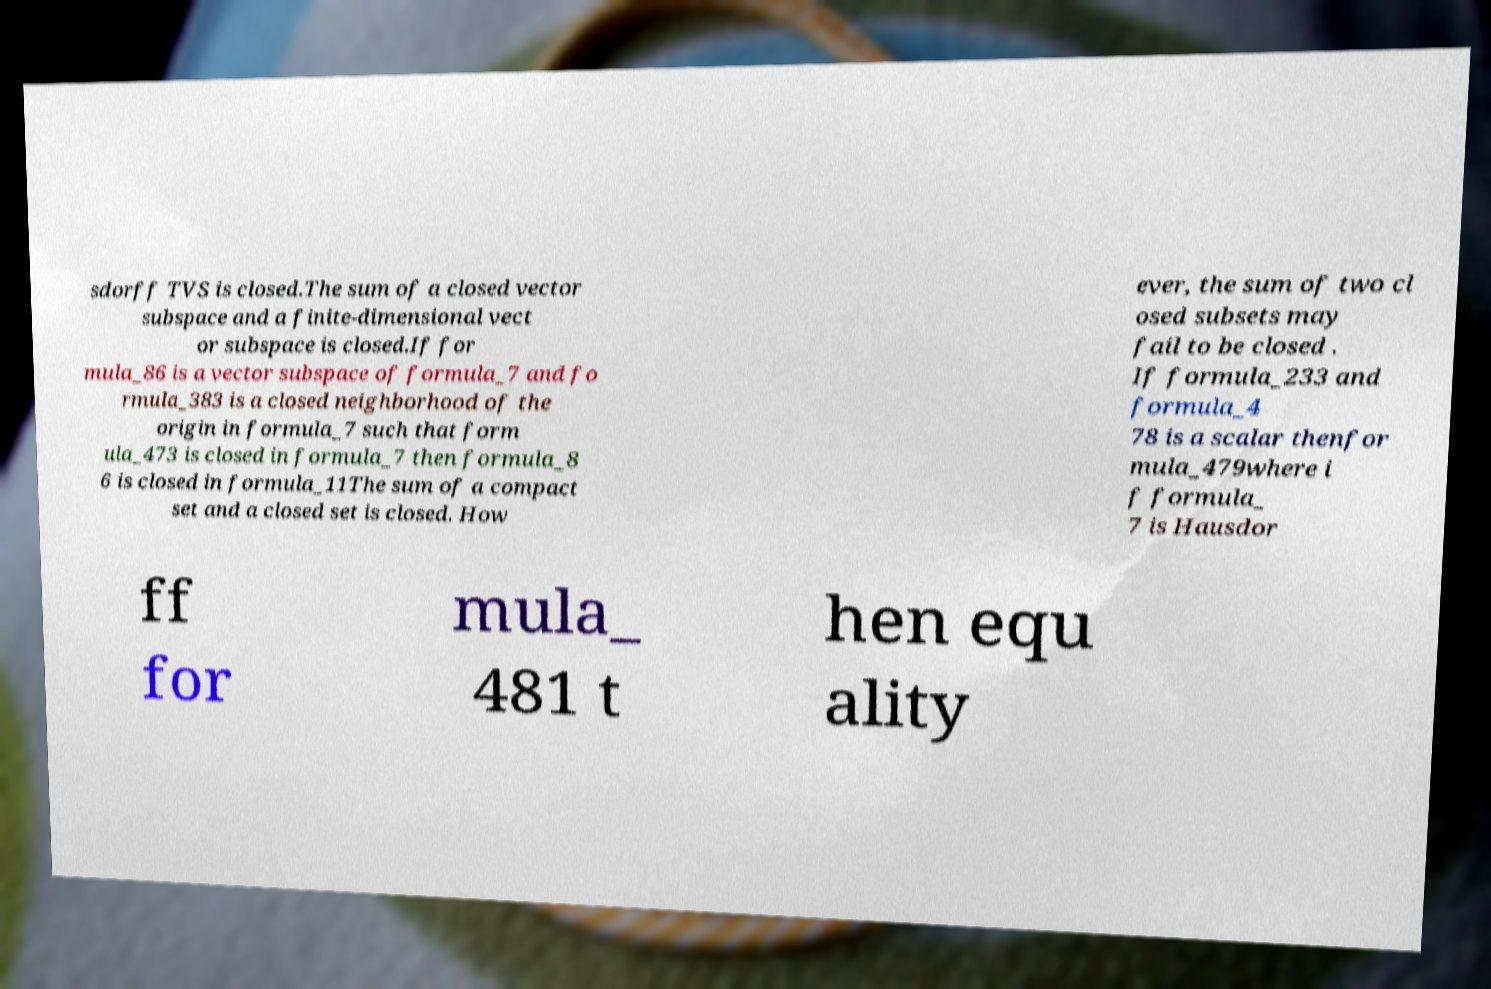I need the written content from this picture converted into text. Can you do that? sdorff TVS is closed.The sum of a closed vector subspace and a finite-dimensional vect or subspace is closed.If for mula_86 is a vector subspace of formula_7 and fo rmula_383 is a closed neighborhood of the origin in formula_7 such that form ula_473 is closed in formula_7 then formula_8 6 is closed in formula_11The sum of a compact set and a closed set is closed. How ever, the sum of two cl osed subsets may fail to be closed . If formula_233 and formula_4 78 is a scalar thenfor mula_479where i f formula_ 7 is Hausdor ff for mula_ 481 t hen equ ality 